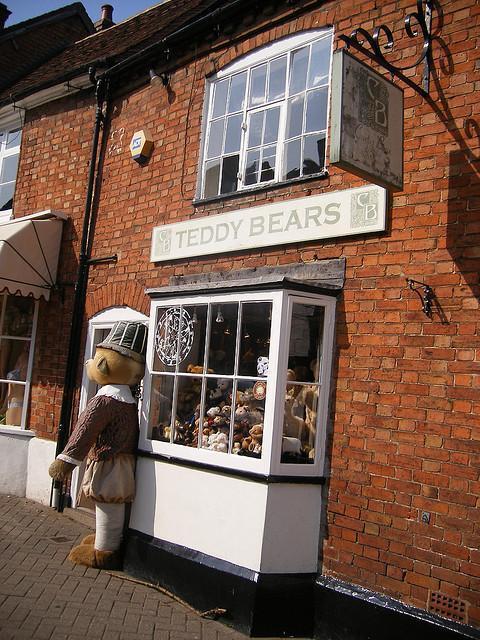What stuffed animal is sold here?
From the following four choices, select the correct answer to address the question.
Options: Dogs, bears, cats, rabbit. Bears. 